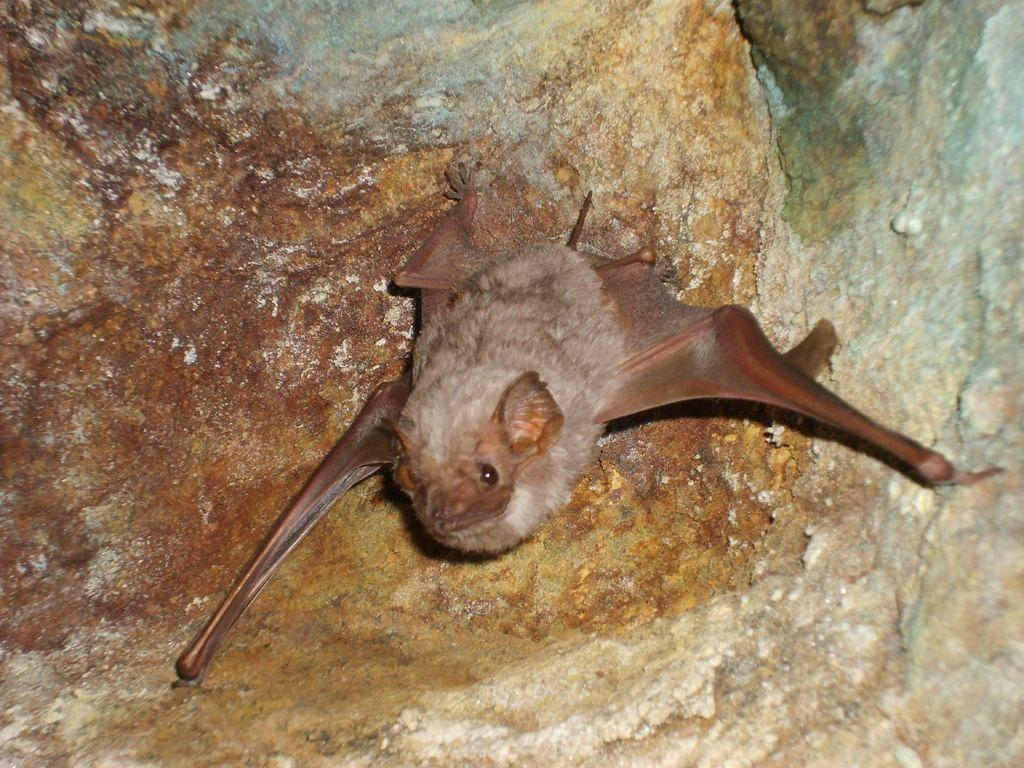What animal is featured in the image? There is a bat in the image. Where is the bat located in the image? The bat is on the wall. What invention is the bat holding in the image? There is no invention present in the image, as the bat is not holding anything. 